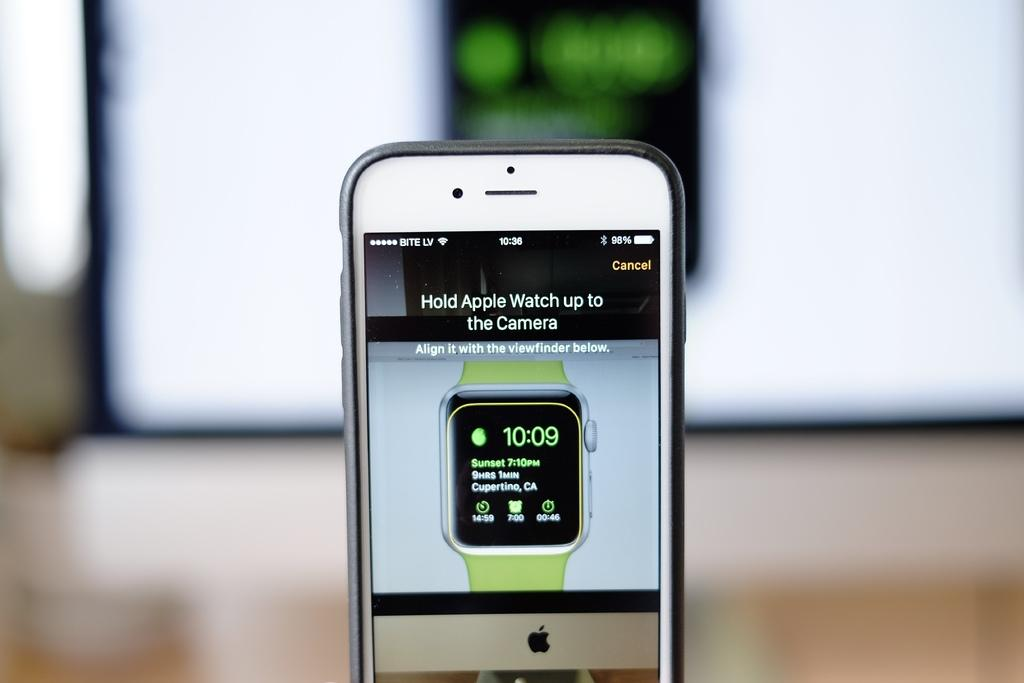<image>
Create a compact narrative representing the image presented. The front screen of a phone showing an apple watch ad 